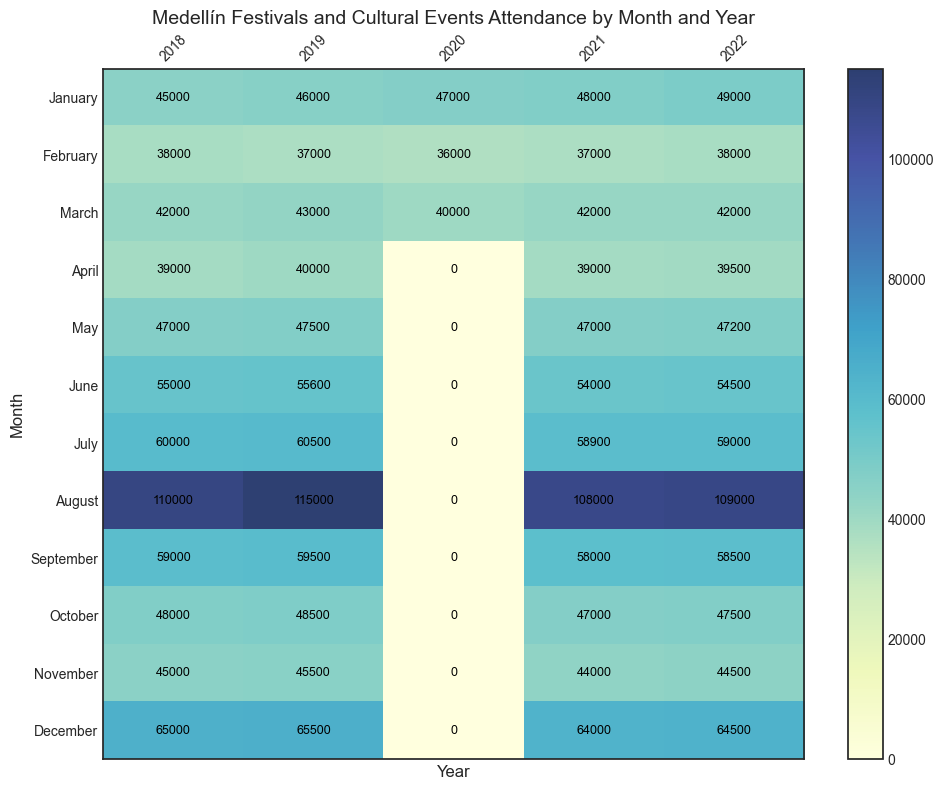Which year had the highest attendance for August? The heatmap clearly shows the attendance numbers for each month and year. By looking at the August column, we can see that 2019 had the highest attendance with 115,000 attendees.
Answer: 2019 How does the attendance in June 2021 compare to June 2020? From the heatmap, you can see that June 2020 had zero attendance due to the pandemic. In contrast, June 2021 had 54,000 attendees. Thus, attendance in June 2021 significantly increased compared to June 2020.
Answer: June 2021 had more attendance What is the average attendance for December over the given years? To find the average, add all December attendance figures (65,000 + 65,500 + 0 + 64,000 + 64,500) and divide by 5. This results in (65,000 + 65,500 + 0 + 64,000 + 64,500) = 259,000, so the average is 259,000 / 5 = 51,800.
Answer: 51,800 Which month in 2020 had the maximum attendance? From the heatmap, it is evident that the only months with attendance in 2020 are January, February, and March. Among these, January had the highest attendance with 47,000 attendees.
Answer: January What is the total attendance for February from 2018 to 2022? Sum the February attendance values: 38,000 (2018) + 37,000 (2019) + 36,000 (2020) + 37,000 (2021) + 38,000 (2022). This results in 38,000 + 37,000 + 36,000 + 37,000 + 38,000 = 186,000.
Answer: 186,000 In which year did March see the least attendance? By looking at the March row, you can see that the year 2020 had the lowest attendance in March with 40,000 attendees.
Answer: 2020 Compare the attendance of May 2019 to May 2021. Which is higher? From the heatmap, you can see that May 2019 had an attendance of 47,500, while May 2021 had an attendance of 47,000. Therefore, May 2019 had a slightly higher attendance.
Answer: May 2019 What trend can you observe in attendance for the month of August from 2018 to 2022? The numbers for August are: 110,000 (2018), 115,000 (2019), 0 (2020), 108,000 (2021), and 109,000 (2022). The trend shows high attendance with a dip to zero in 2020 due to the pandemic and recovery back to high numbers in subsequent years.
Answer: High with exception in 2020 Which month consistently has high attendance across multiple years? By observing the heatmap, August consistently shows high attendance numbers across multiple years (2018: 110,000, 2019: 115,000, 2021: 108,000, 2022: 109,000).
Answer: August What is the difference in attendance between July 2018 and July 2019? From the heatmap, July 2018 had 60,000 attendees and July 2019 had 60,500 attendees. The difference is 60,500 - 60,000 = 500.
Answer: 500 